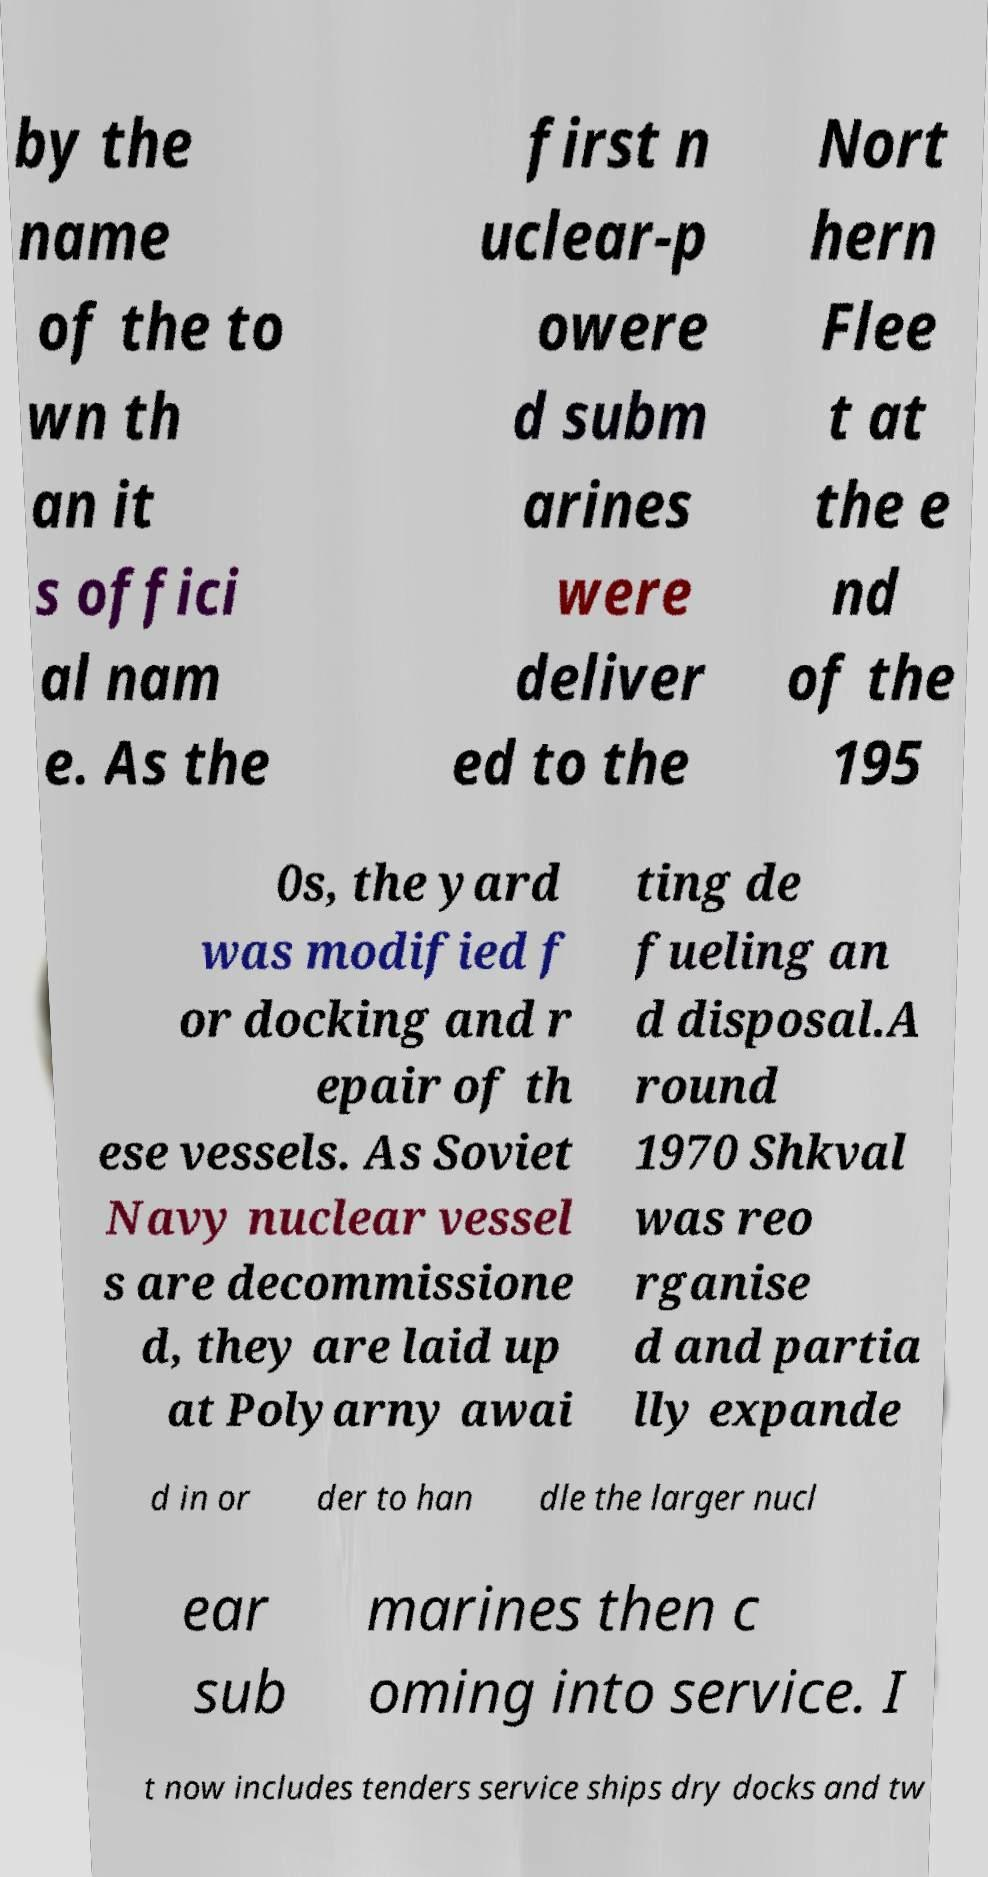I need the written content from this picture converted into text. Can you do that? by the name of the to wn th an it s offici al nam e. As the first n uclear-p owere d subm arines were deliver ed to the Nort hern Flee t at the e nd of the 195 0s, the yard was modified f or docking and r epair of th ese vessels. As Soviet Navy nuclear vessel s are decommissione d, they are laid up at Polyarny awai ting de fueling an d disposal.A round 1970 Shkval was reo rganise d and partia lly expande d in or der to han dle the larger nucl ear sub marines then c oming into service. I t now includes tenders service ships dry docks and tw 